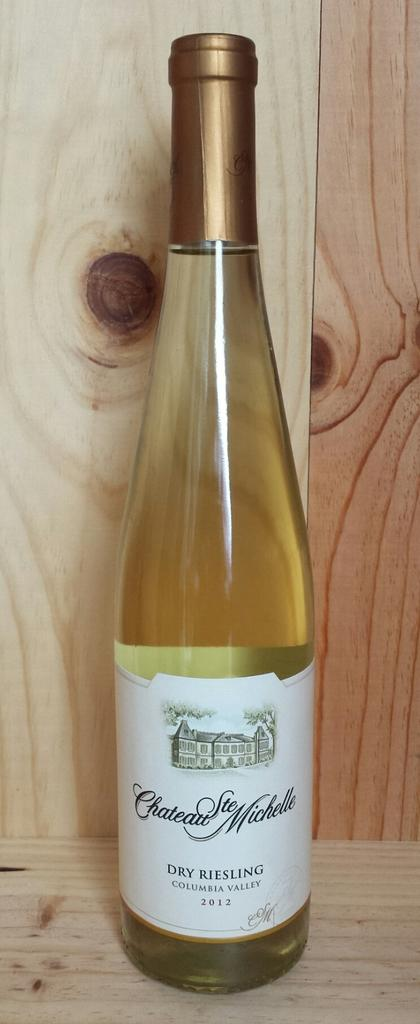What object can be seen in the image? There is a bottle in the image. Where is the bottle located? The bottle is placed on a table. What type of bottle might it be? The bottle may be a wine bottle. Is there any additional information about the bottle? Yes, there is a sticker attached to the bottle. What is the chance of finding a yam inside the bottle? There is no yam present in the image, so it is not possible to determine the chance of finding one inside the bottle. 